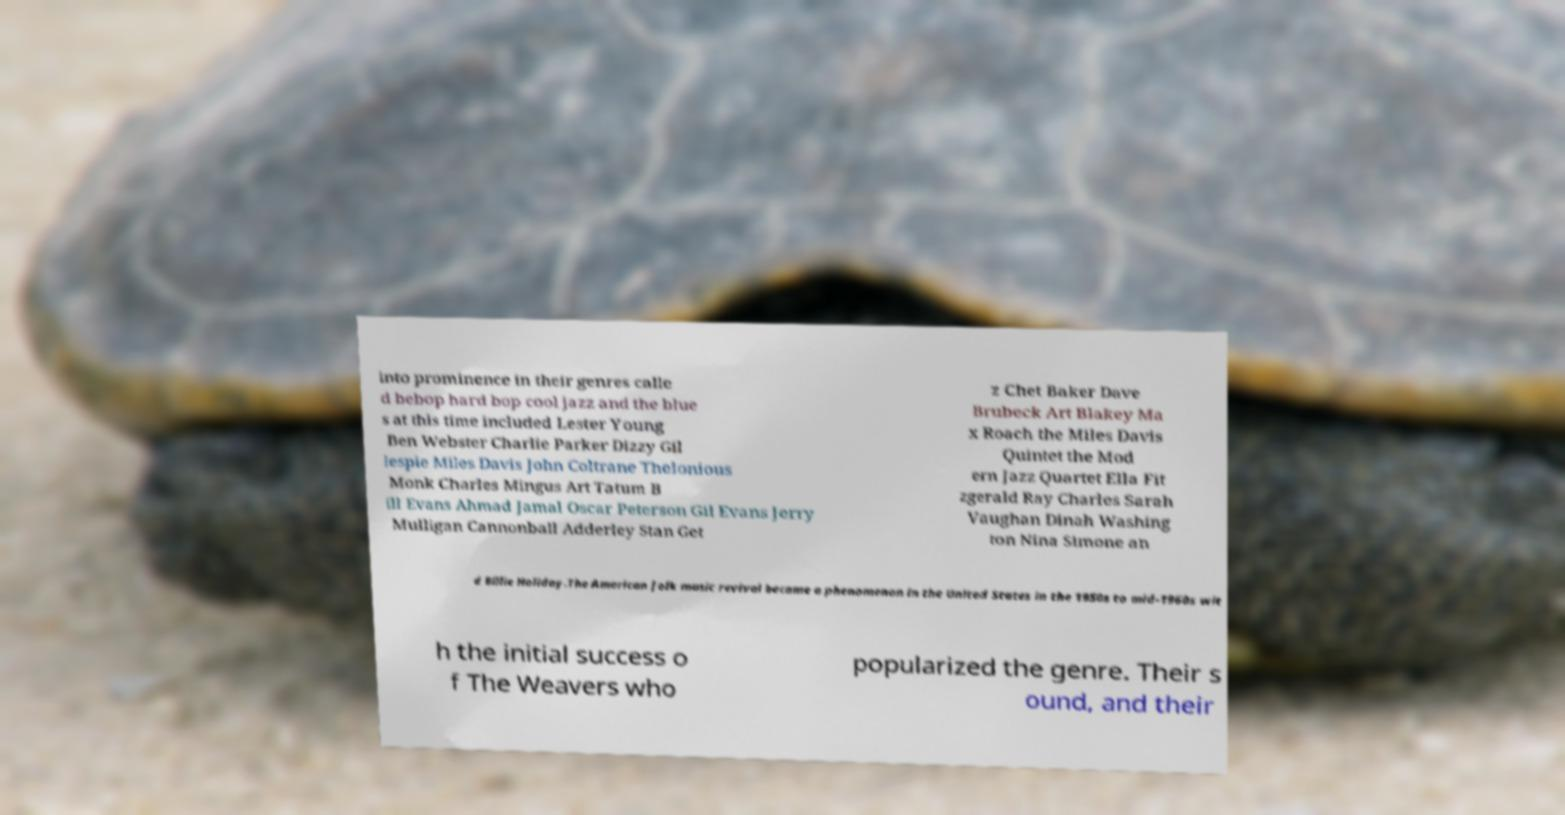Please identify and transcribe the text found in this image. into prominence in their genres calle d bebop hard bop cool jazz and the blue s at this time included Lester Young Ben Webster Charlie Parker Dizzy Gil lespie Miles Davis John Coltrane Thelonious Monk Charles Mingus Art Tatum B ill Evans Ahmad Jamal Oscar Peterson Gil Evans Jerry Mulligan Cannonball Adderley Stan Get z Chet Baker Dave Brubeck Art Blakey Ma x Roach the Miles Davis Quintet the Mod ern Jazz Quartet Ella Fit zgerald Ray Charles Sarah Vaughan Dinah Washing ton Nina Simone an d Billie Holiday.The American folk music revival became a phenomenon in the United States in the 1950s to mid-1960s wit h the initial success o f The Weavers who popularized the genre. Their s ound, and their 